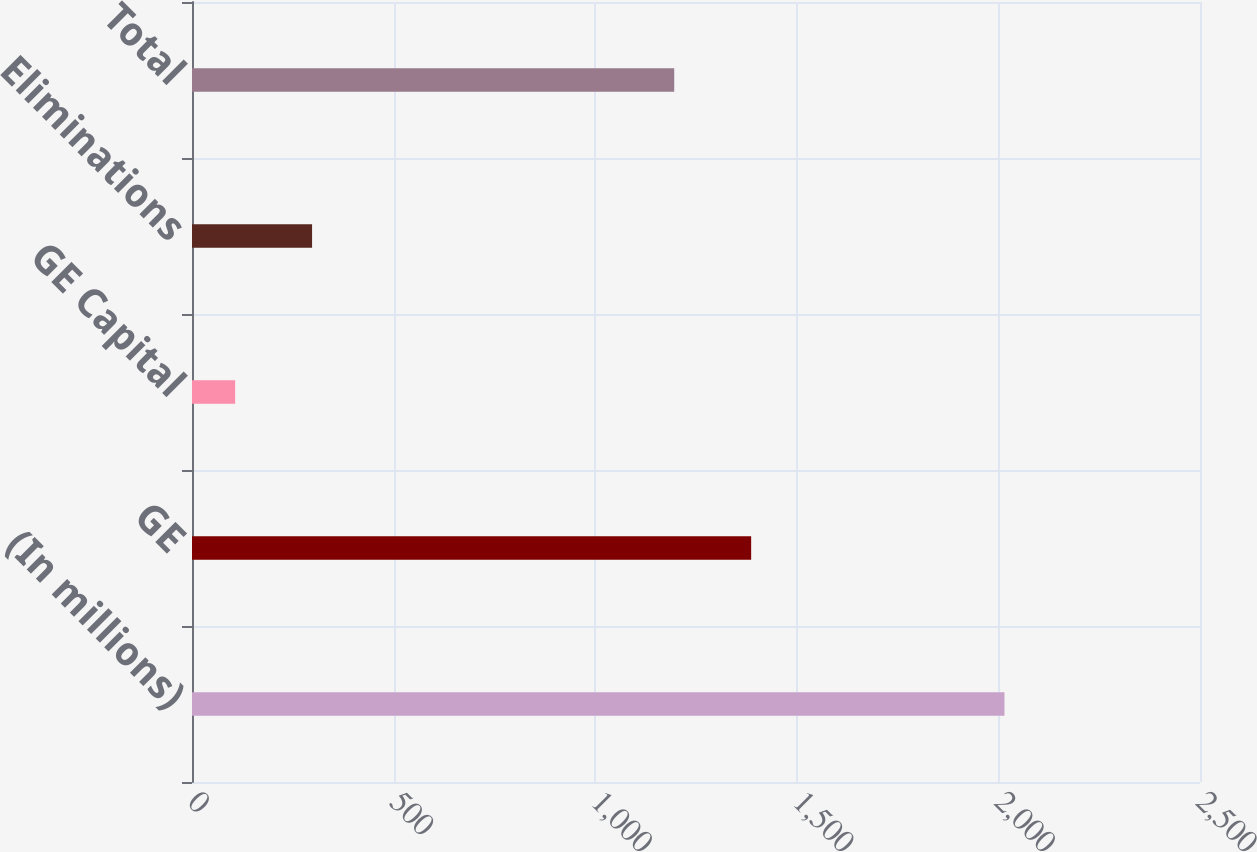<chart> <loc_0><loc_0><loc_500><loc_500><bar_chart><fcel>(In millions)<fcel>GE<fcel>GE Capital<fcel>Eliminations<fcel>Total<nl><fcel>2015<fcel>1386.8<fcel>107<fcel>297.8<fcel>1196<nl></chart> 